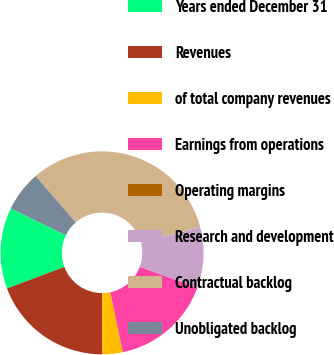<chart> <loc_0><loc_0><loc_500><loc_500><pie_chart><fcel>Years ended December 31<fcel>Revenues<fcel>of total company revenues<fcel>Earnings from operations<fcel>Operating margins<fcel>Research and development<fcel>Contractual backlog<fcel>Unobligated backlog<nl><fcel>12.9%<fcel>19.35%<fcel>3.23%<fcel>16.13%<fcel>0.0%<fcel>9.68%<fcel>32.26%<fcel>6.45%<nl></chart> 